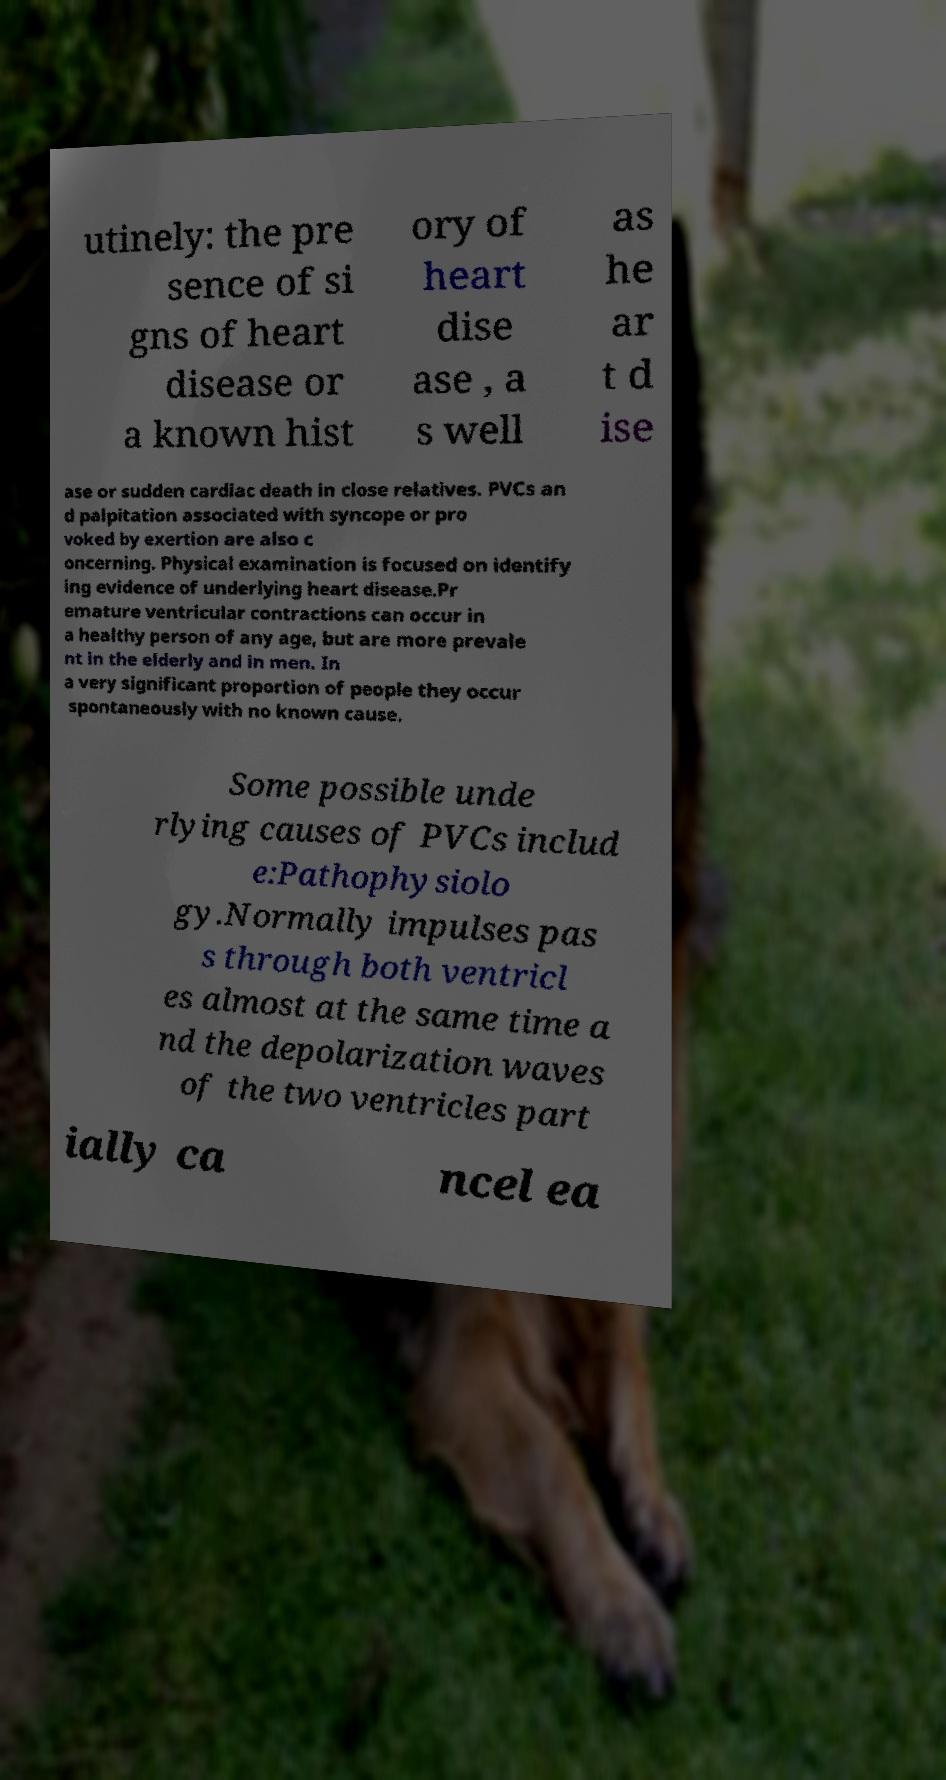I need the written content from this picture converted into text. Can you do that? utinely: the pre sence of si gns of heart disease or a known hist ory of heart dise ase , a s well as he ar t d ise ase or sudden cardiac death in close relatives. PVCs an d palpitation associated with syncope or pro voked by exertion are also c oncerning. Physical examination is focused on identify ing evidence of underlying heart disease.Pr emature ventricular contractions can occur in a healthy person of any age, but are more prevale nt in the elderly and in men. In a very significant proportion of people they occur spontaneously with no known cause. Some possible unde rlying causes of PVCs includ e:Pathophysiolo gy.Normally impulses pas s through both ventricl es almost at the same time a nd the depolarization waves of the two ventricles part ially ca ncel ea 